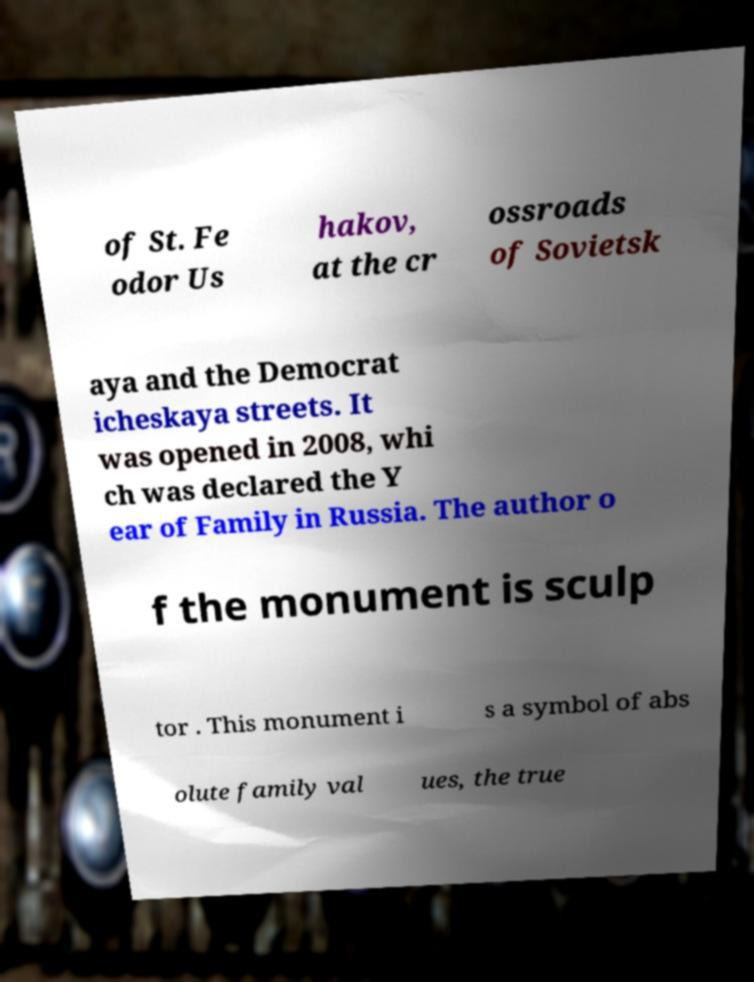Could you assist in decoding the text presented in this image and type it out clearly? of St. Fe odor Us hakov, at the cr ossroads of Sovietsk aya and the Democrat icheskaya streets. It was opened in 2008, whi ch was declared the Y ear of Family in Russia. The author o f the monument is sculp tor . This monument i s a symbol of abs olute family val ues, the true 